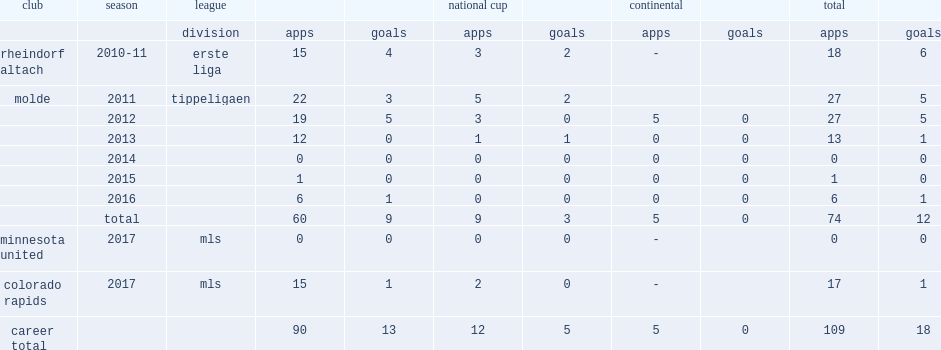Which league did gatt play the molde's match in 2013? Tippeligaen. 